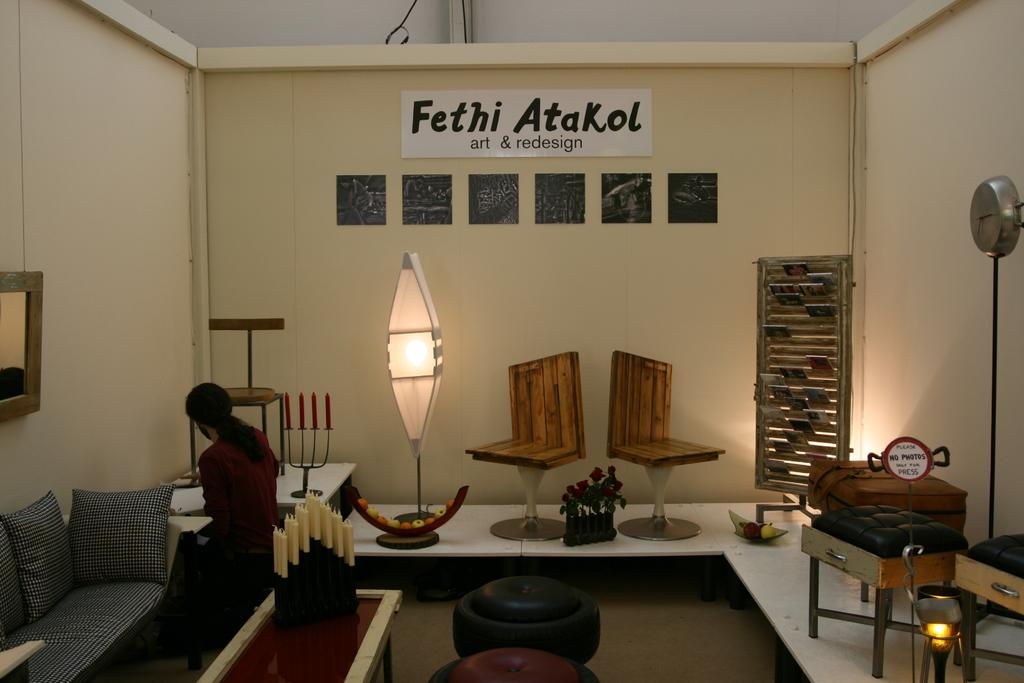Provide a one-sentence caption for the provided image. Person hanging out in a room with a sign that says "Fethi Atakol" on the top of one wall. 